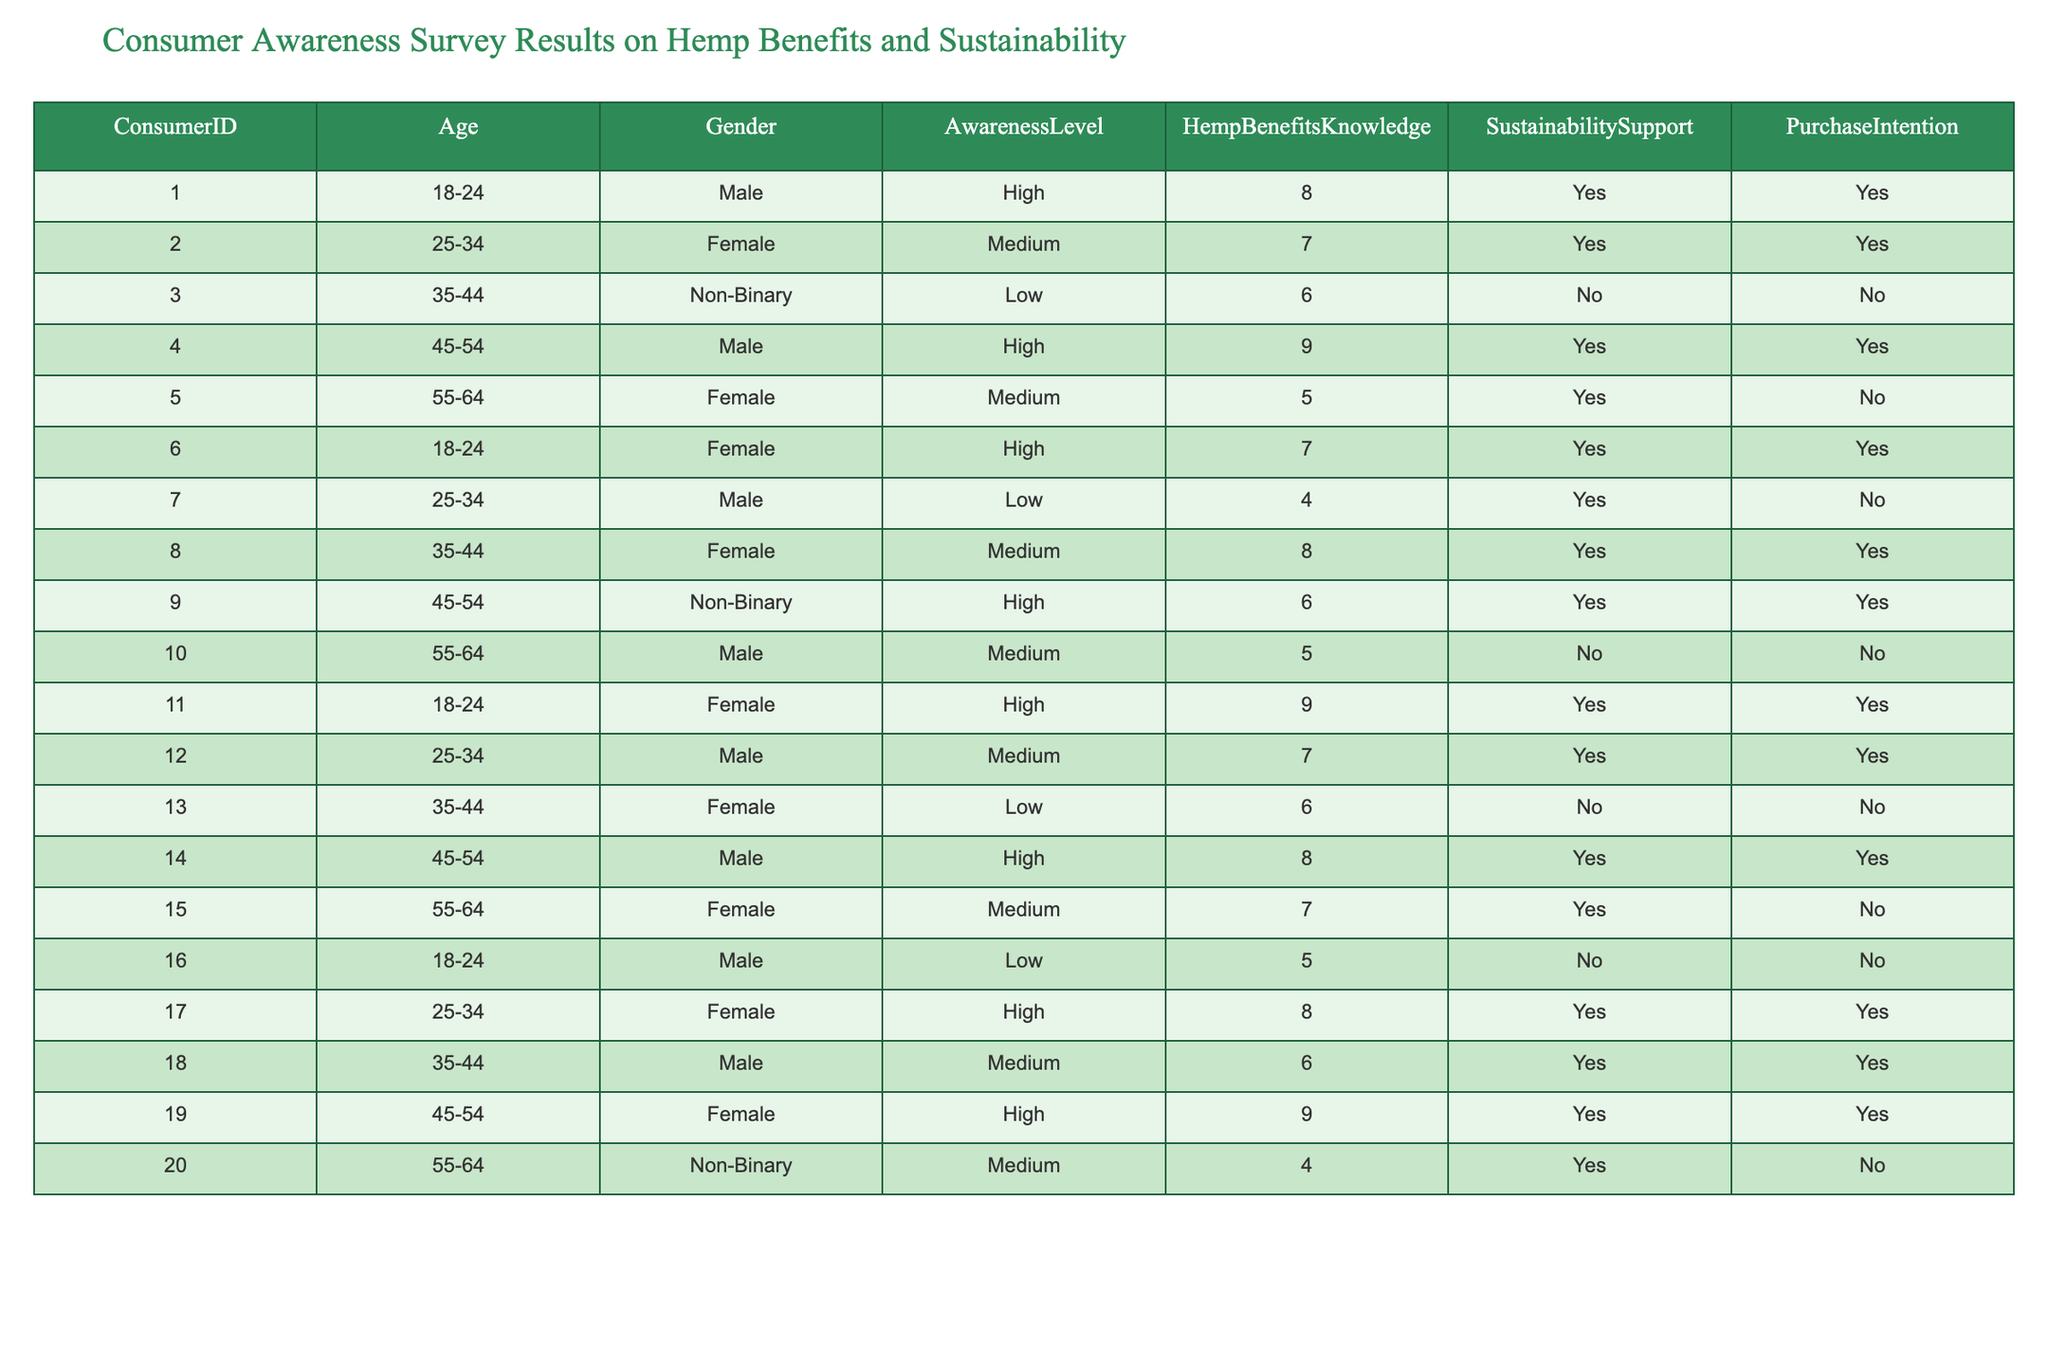What percentage of respondents are aware of the benefits of hemp? To find the percentage of respondents with high awareness of hemp benefits, count those with knowledge level 8 or 9 in the "HempBenefitsKnowledge" column. There are 7 respondents fitting this category out of 20 total respondents, so the percentage is (7/20) * 100 = 35%.
Answer: 35% How many respondents support sustainability in hemp farming? By counting the responses marked "Yes" in the "SustainabilitySupport" column, we find that 12 out of 20 respondents support sustainability in hemp farming.
Answer: 12 What is the average awareness level of respondents aged 18-24? First, identify the awareness levels of respondents aged 18-24: they are High, High, and Low. Assign values to these levels (High=3, Medium=2, Low=1), resulting in values of 3, 3, and 1. The average is (3 + 3 + 1) / 3 = 2.33.
Answer: 2.33 Are there any female respondents who have a low level of knowledge about hemp benefits? Check the "Gender" and "HempBenefitsKnowledge" columns for female respondents with a knowledge score of 1 to 3. There are two respondents fitting this description.
Answer: Yes What is the median age group of the respondents who intend to purchase hemp products? Isolate the age groups of those who marked "Yes" in the "PurchaseIntention" column. The age groups are: 18-24, 25-34, 35-44, 45-54, yielding the sets. Arranging the values in order gives: 18-24, 25-34, 35-44, 45-54. The median is the average of the middle two values: (25-34 + 35-44) which can be approximated as (30 + 40)/2 = 35.
Answer: 35-44 What proportion of male respondents have high knowledge of hemp benefits? Count the male respondents with knowledge scores of 8 or 9: there are 4 among the total of 8 male respondents. Thus, the proportion is 4/8 = 0.5 or 50%.
Answer: 50% How does the purchase intention compare between the age groups 45-54 and 55-64? Count the "PurchaseIntention" entries for 45-54 (Yes=4, No=1) and 55-64 (Yes=0, No=4). Compare totals; thus, respondents aged 45-54 have a higher purchase intention than those aged 55-64.
Answer: 45-54 has higher intention What is the total count of respondents with a medium level of awareness who support sustainability? Count medium-awareness respondents (2, 5, 11) and check if they support sustainability. In total: respondents 2, 5, 12, and 18; out of these, 3 support sustainability.
Answer: 3 How many respondents do not intend to purchase hemp products? Tally all responses marked "No" in the "PurchaseIntention" column. There are 6 in total who marked "No."
Answer: 6 